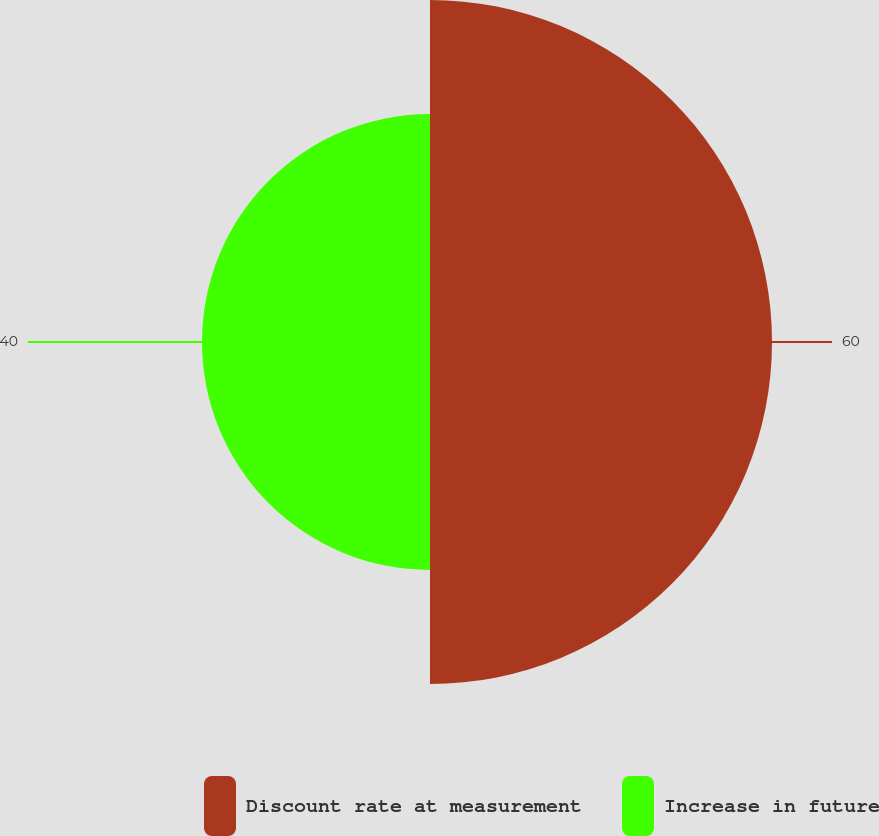Convert chart to OTSL. <chart><loc_0><loc_0><loc_500><loc_500><pie_chart><fcel>Discount rate at measurement<fcel>Increase in future<nl><fcel>60.0%<fcel>40.0%<nl></chart> 